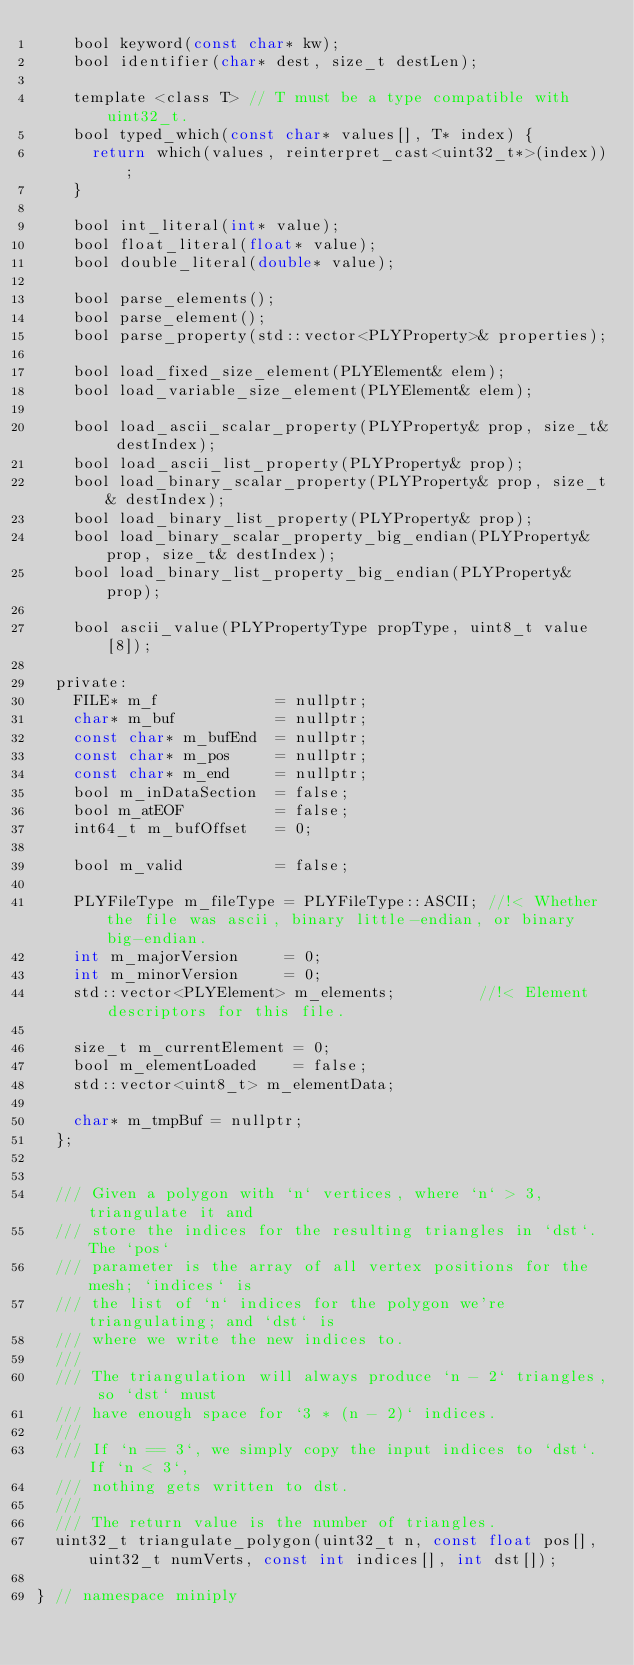Convert code to text. <code><loc_0><loc_0><loc_500><loc_500><_C_>    bool keyword(const char* kw);
    bool identifier(char* dest, size_t destLen);

    template <class T> // T must be a type compatible with uint32_t.
    bool typed_which(const char* values[], T* index) {
      return which(values, reinterpret_cast<uint32_t*>(index));
    }

    bool int_literal(int* value);
    bool float_literal(float* value);
    bool double_literal(double* value);

    bool parse_elements();
    bool parse_element();
    bool parse_property(std::vector<PLYProperty>& properties);

    bool load_fixed_size_element(PLYElement& elem);
    bool load_variable_size_element(PLYElement& elem);

    bool load_ascii_scalar_property(PLYProperty& prop, size_t& destIndex);
    bool load_ascii_list_property(PLYProperty& prop);
    bool load_binary_scalar_property(PLYProperty& prop, size_t& destIndex);
    bool load_binary_list_property(PLYProperty& prop);
    bool load_binary_scalar_property_big_endian(PLYProperty& prop, size_t& destIndex);
    bool load_binary_list_property_big_endian(PLYProperty& prop);

    bool ascii_value(PLYPropertyType propType, uint8_t value[8]);

  private:
    FILE* m_f             = nullptr;
    char* m_buf           = nullptr;
    const char* m_bufEnd  = nullptr;
    const char* m_pos     = nullptr;
    const char* m_end     = nullptr;
    bool m_inDataSection  = false;
    bool m_atEOF          = false;
    int64_t m_bufOffset   = 0;

    bool m_valid          = false;

    PLYFileType m_fileType = PLYFileType::ASCII; //!< Whether the file was ascii, binary little-endian, or binary big-endian.
    int m_majorVersion     = 0;
    int m_minorVersion     = 0;
    std::vector<PLYElement> m_elements;         //!< Element descriptors for this file.

    size_t m_currentElement = 0;
    bool m_elementLoaded    = false;
    std::vector<uint8_t> m_elementData;

    char* m_tmpBuf = nullptr;
  };


  /// Given a polygon with `n` vertices, where `n` > 3, triangulate it and
  /// store the indices for the resulting triangles in `dst`. The `pos`
  /// parameter is the array of all vertex positions for the mesh; `indices` is
  /// the list of `n` indices for the polygon we're triangulating; and `dst` is
  /// where we write the new indices to.
  ///
  /// The triangulation will always produce `n - 2` triangles, so `dst` must
  /// have enough space for `3 * (n - 2)` indices.
  ///
  /// If `n == 3`, we simply copy the input indices to `dst`. If `n < 3`,
  /// nothing gets written to dst.
  ///
  /// The return value is the number of triangles.
  uint32_t triangulate_polygon(uint32_t n, const float pos[], uint32_t numVerts, const int indices[], int dst[]);

} // namespace miniply
</code> 